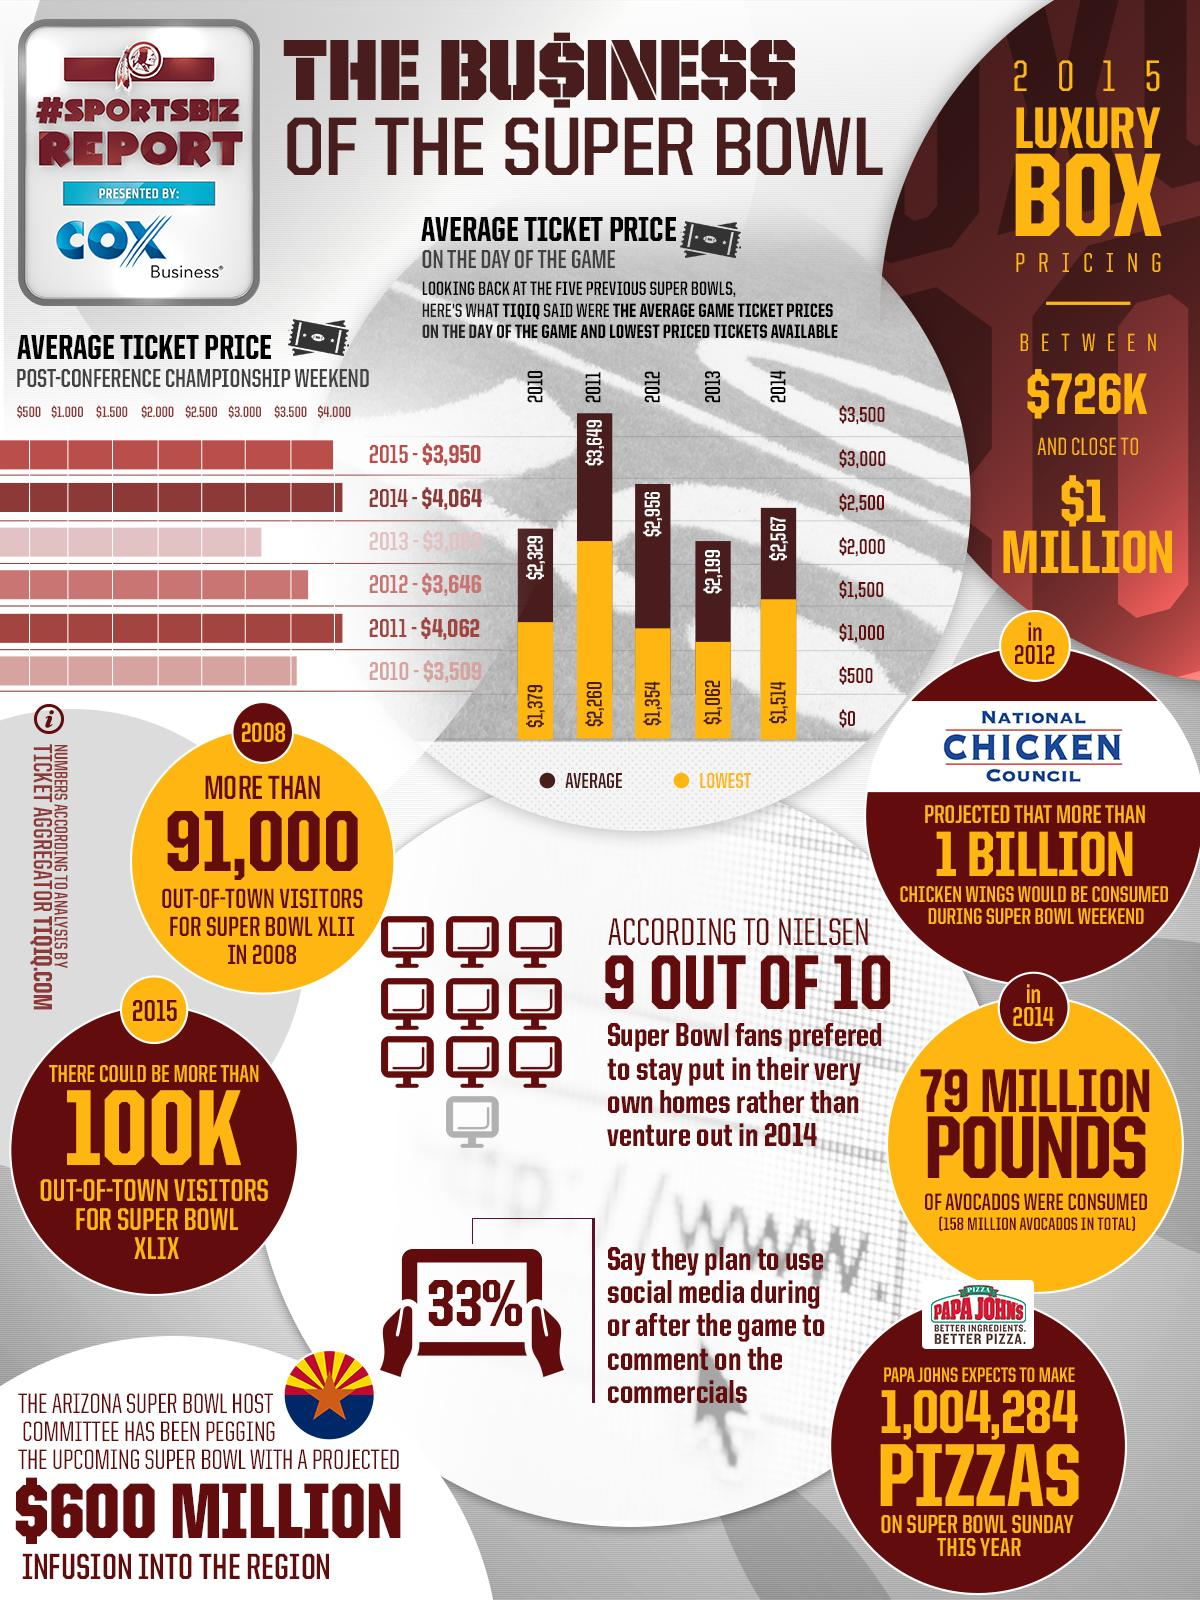List a handful of essential elements in this visual. According to TIQIQ, the average ticket price for the Super Bowl game on the day of the game in 2014 was $2,567. According to the ticket aggregator TIQIQ, the year with the highest average ticket price for the Super Bowl among the five previous games was 2011. According to TIQIQ, the average ticket price for the post-conference championship weekend in 2011 was $4,062. The lowest price ticket available for the 2013 Super Bowl game, according to TIQIQ, was $1,062. There were more than 91,000 out-of-town visitors for Super Bowl XLII in 2008. 